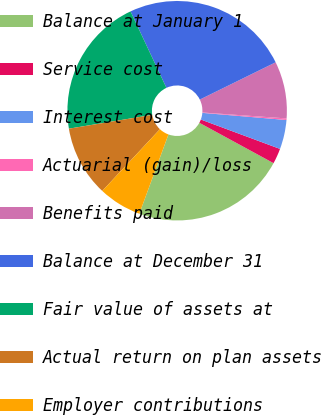Convert chart. <chart><loc_0><loc_0><loc_500><loc_500><pie_chart><fcel>Balance at January 1<fcel>Service cost<fcel>Interest cost<fcel>Actuarial (gain)/loss<fcel>Benefits paid<fcel>Balance at December 31<fcel>Fair value of assets at<fcel>Actual return on plan assets<fcel>Employer contributions<nl><fcel>22.67%<fcel>2.27%<fcel>4.31%<fcel>0.23%<fcel>8.39%<fcel>24.71%<fcel>20.63%<fcel>10.43%<fcel>6.35%<nl></chart> 